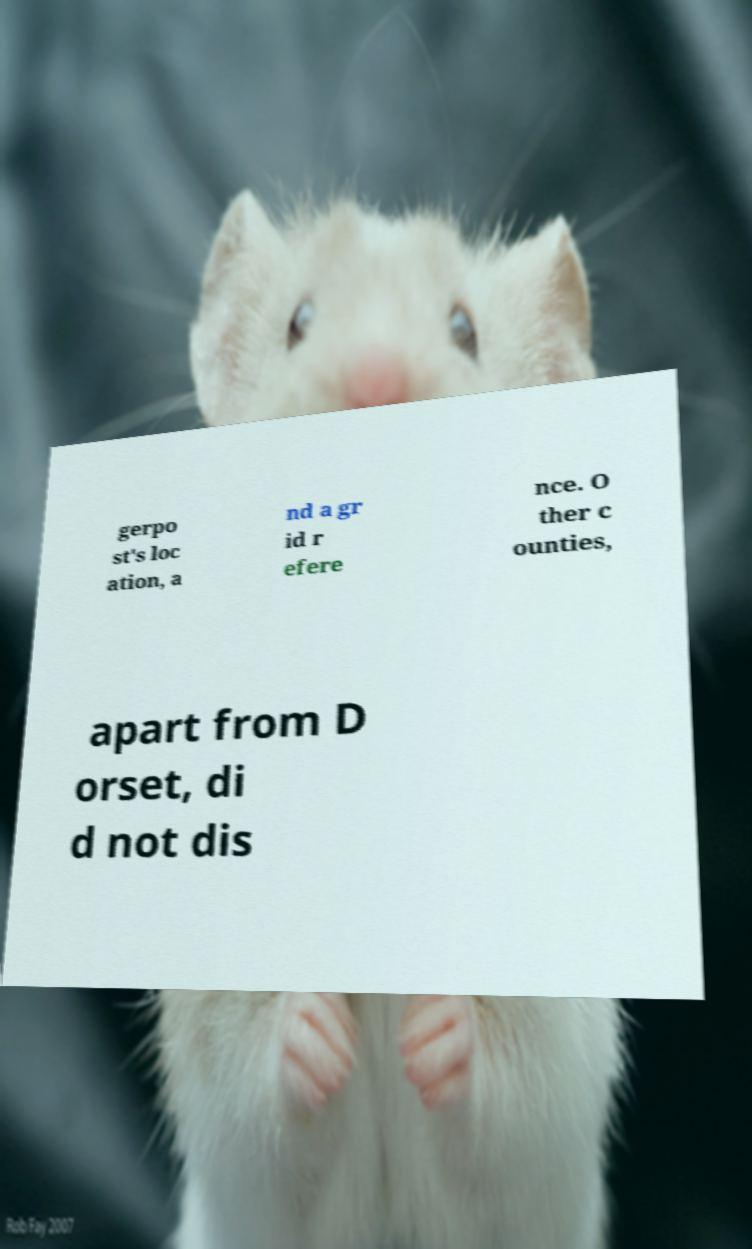Can you read and provide the text displayed in the image?This photo seems to have some interesting text. Can you extract and type it out for me? gerpo st's loc ation, a nd a gr id r efere nce. O ther c ounties, apart from D orset, di d not dis 